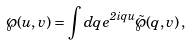<formula> <loc_0><loc_0><loc_500><loc_500>\wp ( u , v ) = \int d q \, e ^ { 2 i q u } { \tilde { \wp } } ( q , v ) \, ,</formula> 